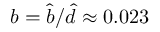<formula> <loc_0><loc_0><loc_500><loc_500>b = \hat { b } / \hat { d } \approx 0 . 0 2 3</formula> 